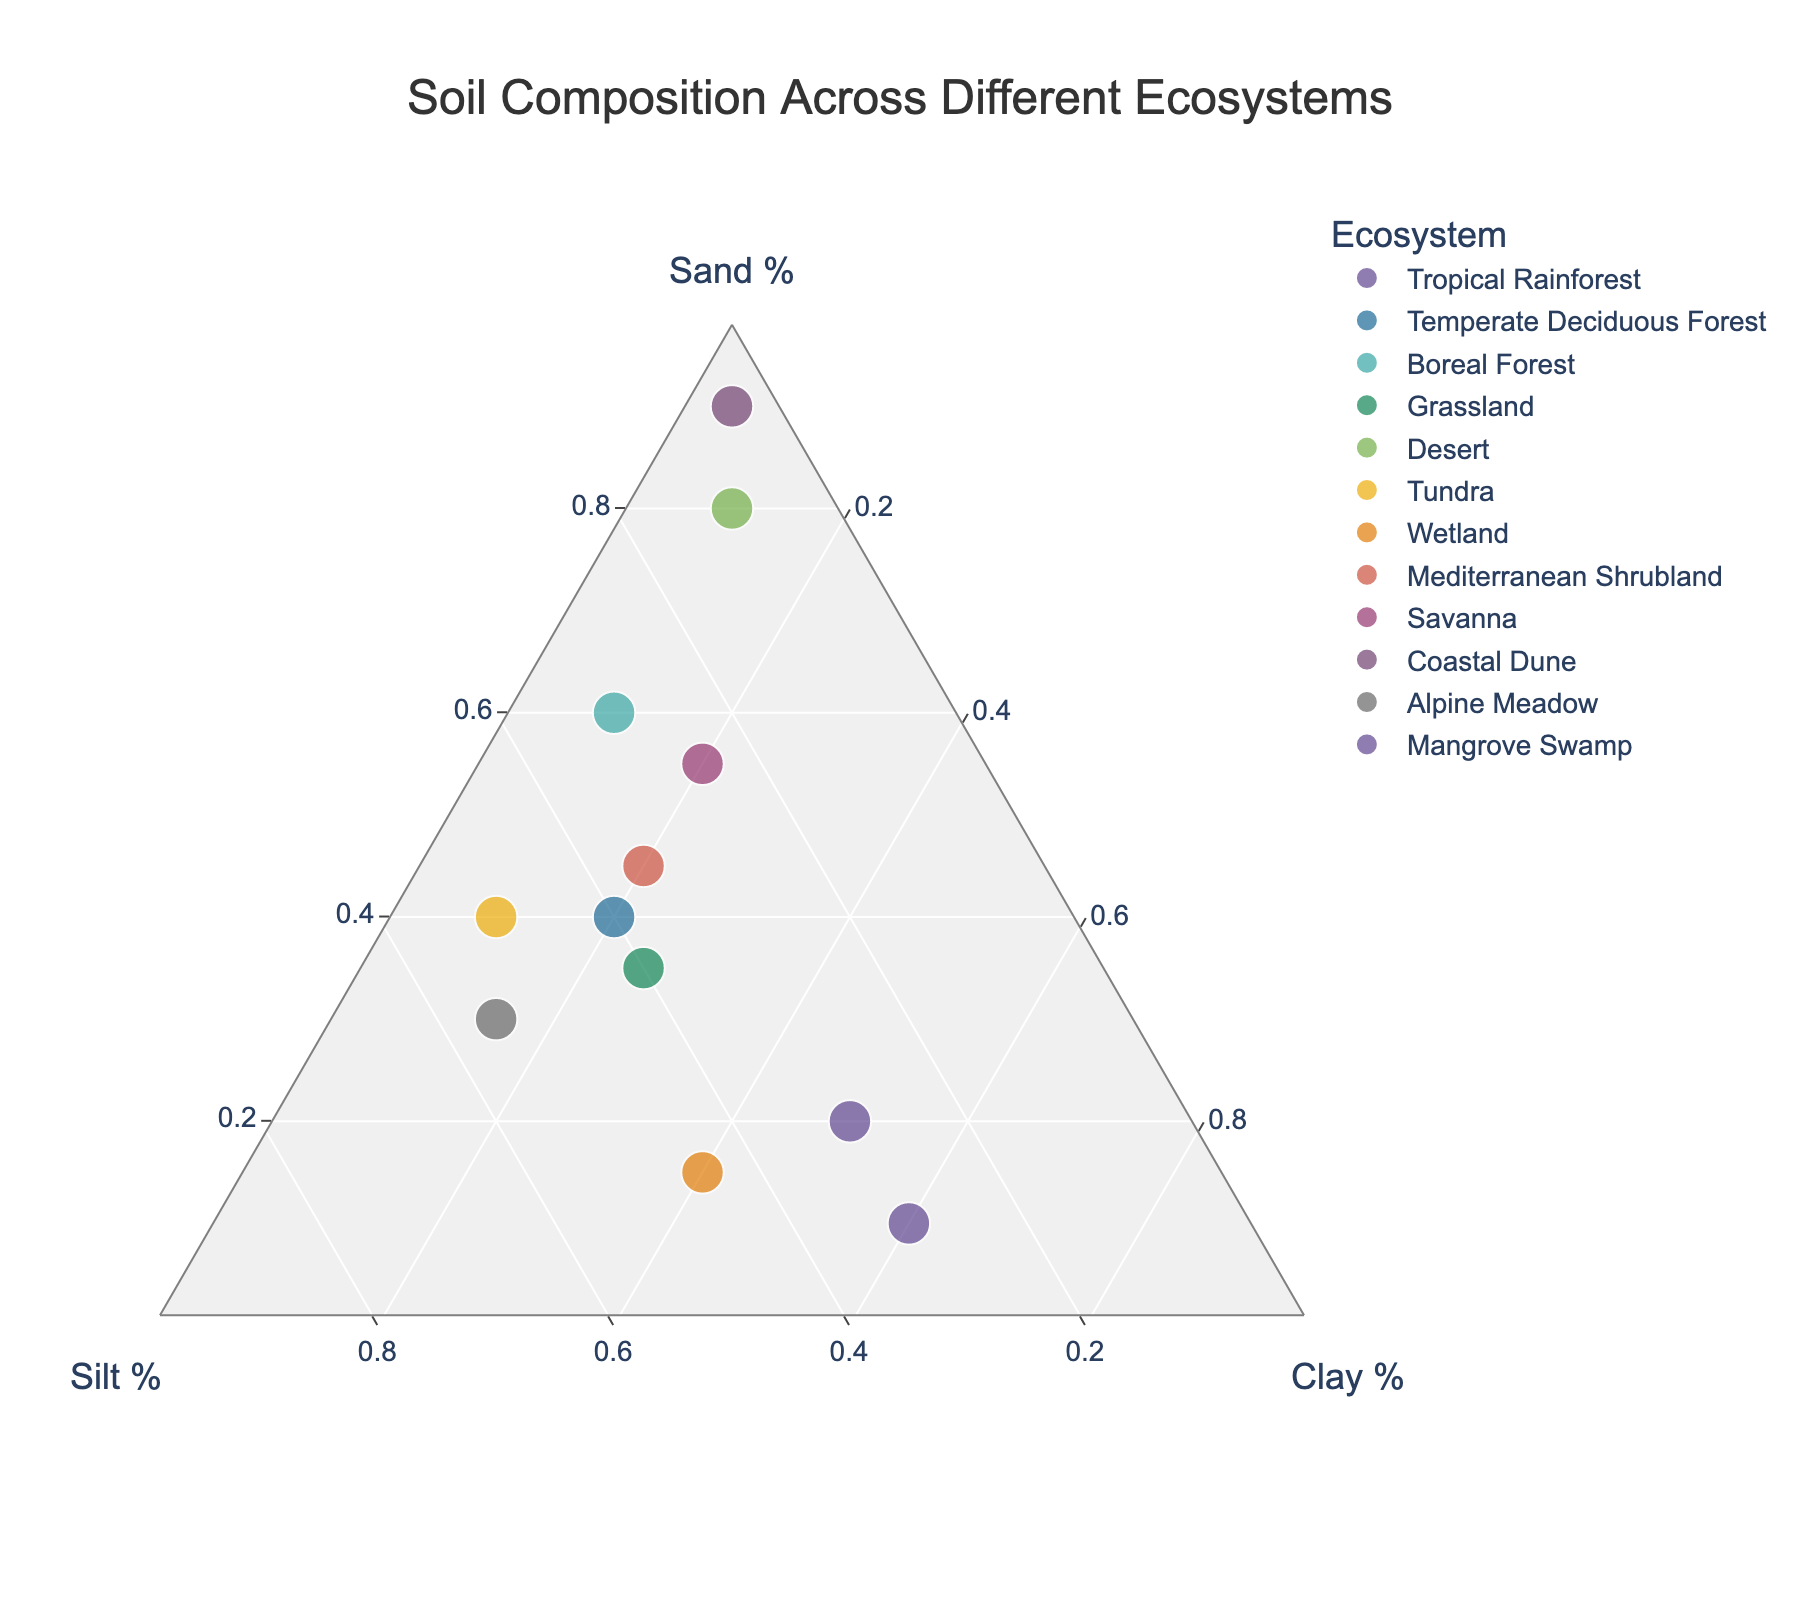What is the title of the figure? The title is often found at the top of the figure in larger and bold font. In this case, the title is specified in that context.
Answer: Soil Composition Across Different Ecosystems Which ecosystem has the highest percentage of Clay? Identify the data point that is positioned closest to the vertex for Clay, which indicates a higher percentage. The Mangrove Swamp is located at the vertex for 60% Clay.
Answer: Mangrove Swamp How many ecosystems have more than 50% Sand? Look at the vertex for Sand and check for the data points that lie above the 50% mark along the axis towards Sand. The ecosystems are Desert, Coastal Dune, and Savanna.
Answer: 3 What are the Sand, Silt, and Clay percentages for the Tropical Rainforest? Hover over the data point for Tropical Rainforest to find the percentages listed in the hover information.
Answer: Sand: 20%, Silt: 30%, Clay: 50% Which ecosystem has the most evenly distributed soil composition? Identify the data point closest to the center of the ternary plot, which suggests an even distribution between Sand, Silt, and Clay. Temperate Deciduous Forest, with 40% Sand, 40% Silt, and 20% Clay, is the closest.
Answer: Temperate Deciduous Forest Compare the Sand content between the Wetland and Tundra ecosystems. Which has more Sand? Hover over the Wetland and Tundra points to read their Sand percentages. Wetland has 15% Sand, and Tundra has 40% Sand.
Answer: Tundra If you average the Clay contents of all the ecosystems, what would it be? Sum all the Clay percentages (50+20+10+25+10+10+40+20+20+5+15+60 = 285) and divide by the number of ecosystems (12).
Answer: 23.75% Which ecosystem is the closest to having equal parts of Sand and Silt? Check the data points to find which one has similar percentages of Sand and Silt. The Temperate Deciduous Forest has 40% Sand and 40% Silt.
Answer: Temperate Deciduous Forest What are the ecosystems with less than 20% Silt? Scan for data points positioned below the 20% Silt mark. Ecosystems below that would be Desert and Coastal Dune.
Answer: Desert, Coastal Dune 